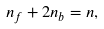<formula> <loc_0><loc_0><loc_500><loc_500>n _ { f } + 2 n _ { b } = n ,</formula> 